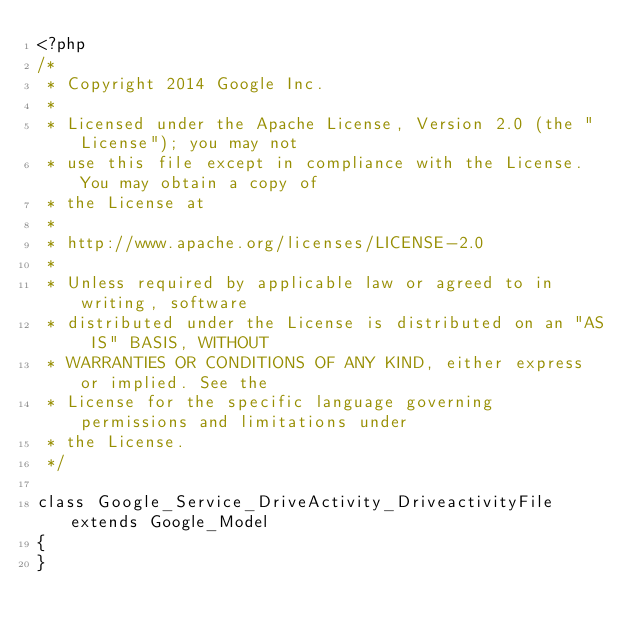Convert code to text. <code><loc_0><loc_0><loc_500><loc_500><_PHP_><?php
/*
 * Copyright 2014 Google Inc.
 *
 * Licensed under the Apache License, Version 2.0 (the "License"); you may not
 * use this file except in compliance with the License. You may obtain a copy of
 * the License at
 *
 * http://www.apache.org/licenses/LICENSE-2.0
 *
 * Unless required by applicable law or agreed to in writing, software
 * distributed under the License is distributed on an "AS IS" BASIS, WITHOUT
 * WARRANTIES OR CONDITIONS OF ANY KIND, either express or implied. See the
 * License for the specific language governing permissions and limitations under
 * the License.
 */

class Google_Service_DriveActivity_DriveactivityFile extends Google_Model
{
}
</code> 